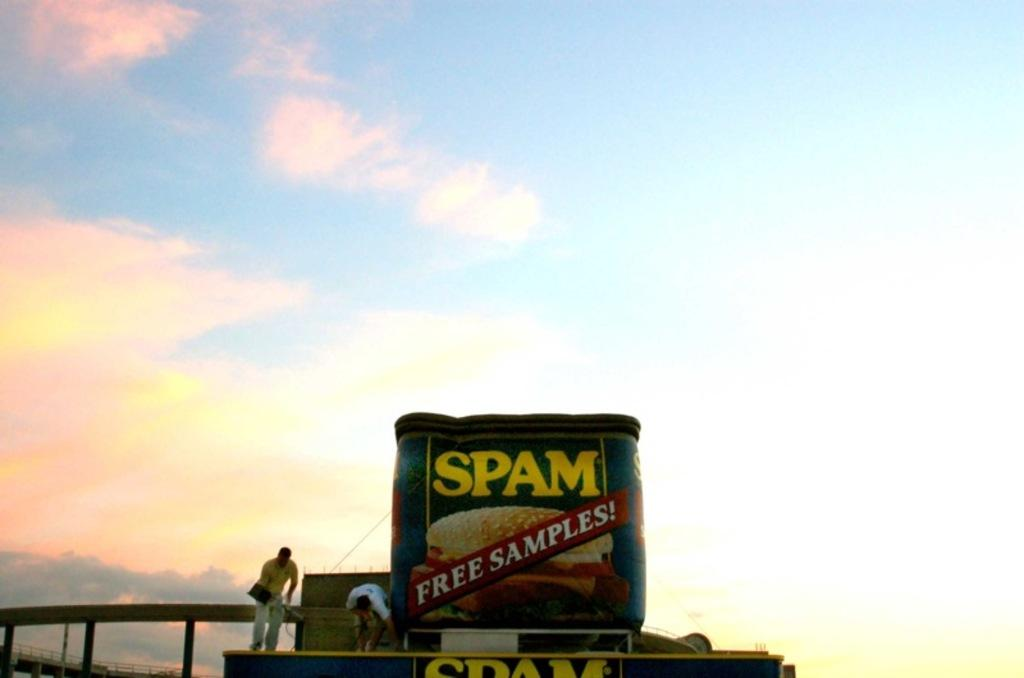<image>
Offer a succinct explanation of the picture presented. a package for a food that is called spam 